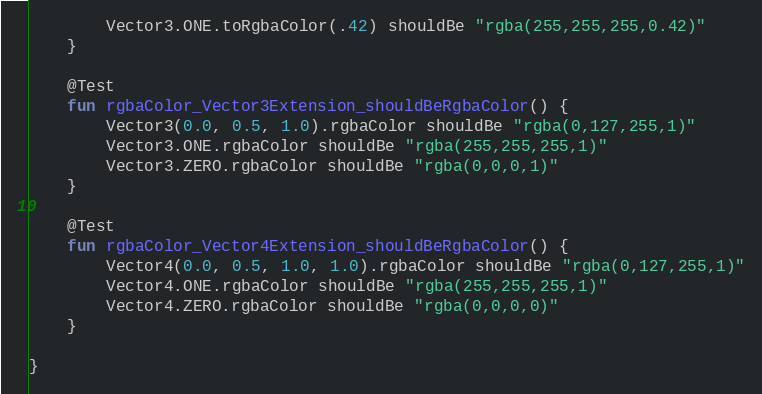Convert code to text. <code><loc_0><loc_0><loc_500><loc_500><_Kotlin_>        Vector3.ONE.toRgbaColor(.42) shouldBe "rgba(255,255,255,0.42)"
    }

    @Test
    fun rgbaColor_Vector3Extension_shouldBeRgbaColor() {
        Vector3(0.0, 0.5, 1.0).rgbaColor shouldBe "rgba(0,127,255,1)"
        Vector3.ONE.rgbaColor shouldBe "rgba(255,255,255,1)"
        Vector3.ZERO.rgbaColor shouldBe "rgba(0,0,0,1)"
    }

    @Test
    fun rgbaColor_Vector4Extension_shouldBeRgbaColor() {
        Vector4(0.0, 0.5, 1.0, 1.0).rgbaColor shouldBe "rgba(0,127,255,1)"
        Vector4.ONE.rgbaColor shouldBe "rgba(255,255,255,1)"
        Vector4.ZERO.rgbaColor shouldBe "rgba(0,0,0,0)"
    }

}
</code> 